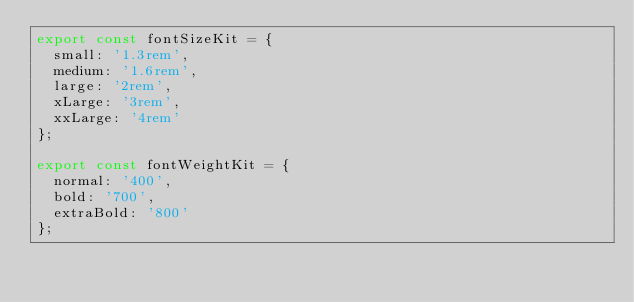<code> <loc_0><loc_0><loc_500><loc_500><_TypeScript_>export const fontSizeKit = {
  small: '1.3rem',
  medium: '1.6rem',
  large: '2rem',
  xLarge: '3rem',
  xxLarge: '4rem'
};

export const fontWeightKit = {
  normal: '400',
  bold: '700',
  extraBold: '800'
};
</code> 